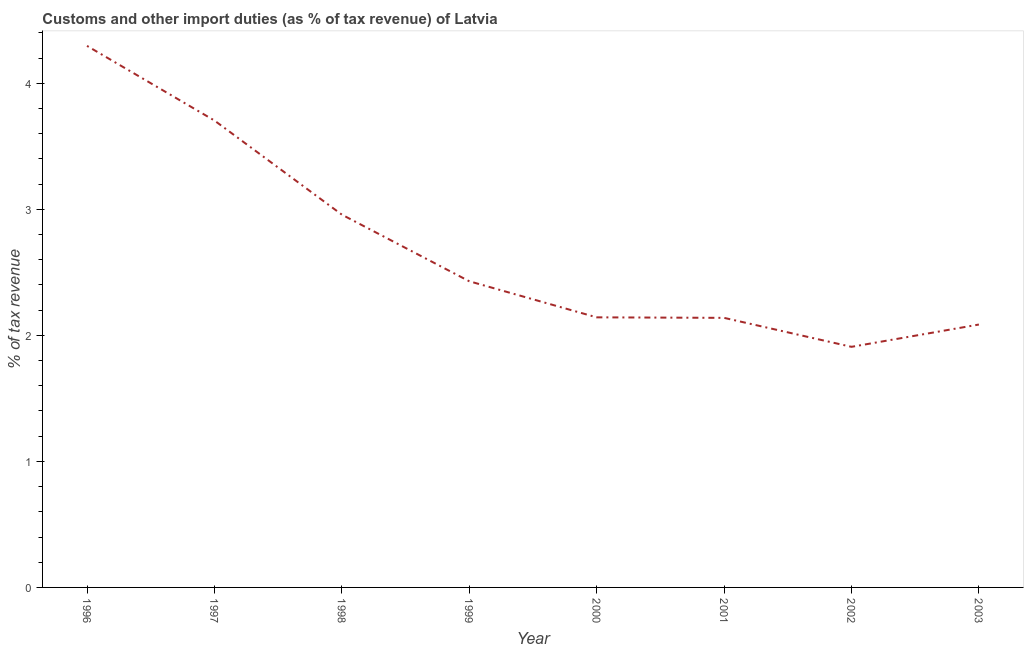What is the customs and other import duties in 2002?
Make the answer very short. 1.91. Across all years, what is the maximum customs and other import duties?
Your response must be concise. 4.3. Across all years, what is the minimum customs and other import duties?
Offer a very short reply. 1.91. What is the sum of the customs and other import duties?
Provide a short and direct response. 21.66. What is the difference between the customs and other import duties in 1996 and 1999?
Offer a terse response. 1.87. What is the average customs and other import duties per year?
Give a very brief answer. 2.71. What is the median customs and other import duties?
Keep it short and to the point. 2.29. In how many years, is the customs and other import duties greater than 3.4 %?
Your answer should be compact. 2. Do a majority of the years between 1998 and 2000 (inclusive) have customs and other import duties greater than 2 %?
Provide a short and direct response. Yes. What is the ratio of the customs and other import duties in 1996 to that in 1998?
Make the answer very short. 1.45. What is the difference between the highest and the second highest customs and other import duties?
Offer a terse response. 0.59. What is the difference between the highest and the lowest customs and other import duties?
Ensure brevity in your answer.  2.39. In how many years, is the customs and other import duties greater than the average customs and other import duties taken over all years?
Provide a succinct answer. 3. Does the customs and other import duties monotonically increase over the years?
Your answer should be compact. No. How many lines are there?
Give a very brief answer. 1. What is the difference between two consecutive major ticks on the Y-axis?
Offer a terse response. 1. Are the values on the major ticks of Y-axis written in scientific E-notation?
Provide a succinct answer. No. What is the title of the graph?
Offer a terse response. Customs and other import duties (as % of tax revenue) of Latvia. What is the label or title of the X-axis?
Make the answer very short. Year. What is the label or title of the Y-axis?
Make the answer very short. % of tax revenue. What is the % of tax revenue of 1996?
Your answer should be compact. 4.3. What is the % of tax revenue in 1997?
Ensure brevity in your answer.  3.7. What is the % of tax revenue in 1998?
Provide a succinct answer. 2.96. What is the % of tax revenue in 1999?
Ensure brevity in your answer.  2.43. What is the % of tax revenue in 2000?
Ensure brevity in your answer.  2.14. What is the % of tax revenue of 2001?
Your answer should be compact. 2.14. What is the % of tax revenue in 2002?
Provide a short and direct response. 1.91. What is the % of tax revenue in 2003?
Ensure brevity in your answer.  2.09. What is the difference between the % of tax revenue in 1996 and 1997?
Provide a succinct answer. 0.59. What is the difference between the % of tax revenue in 1996 and 1998?
Your response must be concise. 1.34. What is the difference between the % of tax revenue in 1996 and 1999?
Your response must be concise. 1.87. What is the difference between the % of tax revenue in 1996 and 2000?
Your answer should be compact. 2.15. What is the difference between the % of tax revenue in 1996 and 2001?
Your answer should be compact. 2.16. What is the difference between the % of tax revenue in 1996 and 2002?
Make the answer very short. 2.39. What is the difference between the % of tax revenue in 1996 and 2003?
Your response must be concise. 2.21. What is the difference between the % of tax revenue in 1997 and 1998?
Your answer should be very brief. 0.75. What is the difference between the % of tax revenue in 1997 and 1999?
Your answer should be compact. 1.28. What is the difference between the % of tax revenue in 1997 and 2000?
Keep it short and to the point. 1.56. What is the difference between the % of tax revenue in 1997 and 2001?
Your answer should be compact. 1.57. What is the difference between the % of tax revenue in 1997 and 2002?
Make the answer very short. 1.8. What is the difference between the % of tax revenue in 1997 and 2003?
Ensure brevity in your answer.  1.62. What is the difference between the % of tax revenue in 1998 and 1999?
Make the answer very short. 0.53. What is the difference between the % of tax revenue in 1998 and 2000?
Provide a short and direct response. 0.81. What is the difference between the % of tax revenue in 1998 and 2001?
Provide a succinct answer. 0.82. What is the difference between the % of tax revenue in 1998 and 2002?
Give a very brief answer. 1.05. What is the difference between the % of tax revenue in 1998 and 2003?
Your answer should be compact. 0.87. What is the difference between the % of tax revenue in 1999 and 2000?
Keep it short and to the point. 0.29. What is the difference between the % of tax revenue in 1999 and 2001?
Offer a terse response. 0.29. What is the difference between the % of tax revenue in 1999 and 2002?
Offer a very short reply. 0.52. What is the difference between the % of tax revenue in 1999 and 2003?
Make the answer very short. 0.34. What is the difference between the % of tax revenue in 2000 and 2001?
Your response must be concise. 0. What is the difference between the % of tax revenue in 2000 and 2002?
Your response must be concise. 0.23. What is the difference between the % of tax revenue in 2000 and 2003?
Your answer should be very brief. 0.06. What is the difference between the % of tax revenue in 2001 and 2002?
Provide a short and direct response. 0.23. What is the difference between the % of tax revenue in 2001 and 2003?
Your response must be concise. 0.05. What is the difference between the % of tax revenue in 2002 and 2003?
Make the answer very short. -0.18. What is the ratio of the % of tax revenue in 1996 to that in 1997?
Your answer should be very brief. 1.16. What is the ratio of the % of tax revenue in 1996 to that in 1998?
Keep it short and to the point. 1.45. What is the ratio of the % of tax revenue in 1996 to that in 1999?
Keep it short and to the point. 1.77. What is the ratio of the % of tax revenue in 1996 to that in 2000?
Your answer should be very brief. 2. What is the ratio of the % of tax revenue in 1996 to that in 2001?
Offer a very short reply. 2.01. What is the ratio of the % of tax revenue in 1996 to that in 2002?
Keep it short and to the point. 2.25. What is the ratio of the % of tax revenue in 1996 to that in 2003?
Offer a very short reply. 2.06. What is the ratio of the % of tax revenue in 1997 to that in 1998?
Make the answer very short. 1.25. What is the ratio of the % of tax revenue in 1997 to that in 1999?
Provide a short and direct response. 1.52. What is the ratio of the % of tax revenue in 1997 to that in 2000?
Provide a short and direct response. 1.73. What is the ratio of the % of tax revenue in 1997 to that in 2001?
Provide a short and direct response. 1.73. What is the ratio of the % of tax revenue in 1997 to that in 2002?
Your answer should be compact. 1.94. What is the ratio of the % of tax revenue in 1997 to that in 2003?
Keep it short and to the point. 1.78. What is the ratio of the % of tax revenue in 1998 to that in 1999?
Make the answer very short. 1.22. What is the ratio of the % of tax revenue in 1998 to that in 2000?
Keep it short and to the point. 1.38. What is the ratio of the % of tax revenue in 1998 to that in 2001?
Give a very brief answer. 1.38. What is the ratio of the % of tax revenue in 1998 to that in 2002?
Keep it short and to the point. 1.55. What is the ratio of the % of tax revenue in 1998 to that in 2003?
Keep it short and to the point. 1.42. What is the ratio of the % of tax revenue in 1999 to that in 2000?
Your answer should be compact. 1.13. What is the ratio of the % of tax revenue in 1999 to that in 2001?
Your answer should be very brief. 1.14. What is the ratio of the % of tax revenue in 1999 to that in 2002?
Give a very brief answer. 1.27. What is the ratio of the % of tax revenue in 1999 to that in 2003?
Your answer should be very brief. 1.17. What is the ratio of the % of tax revenue in 2000 to that in 2002?
Make the answer very short. 1.12. What is the ratio of the % of tax revenue in 2001 to that in 2002?
Give a very brief answer. 1.12. What is the ratio of the % of tax revenue in 2001 to that in 2003?
Offer a terse response. 1.02. What is the ratio of the % of tax revenue in 2002 to that in 2003?
Provide a short and direct response. 0.92. 